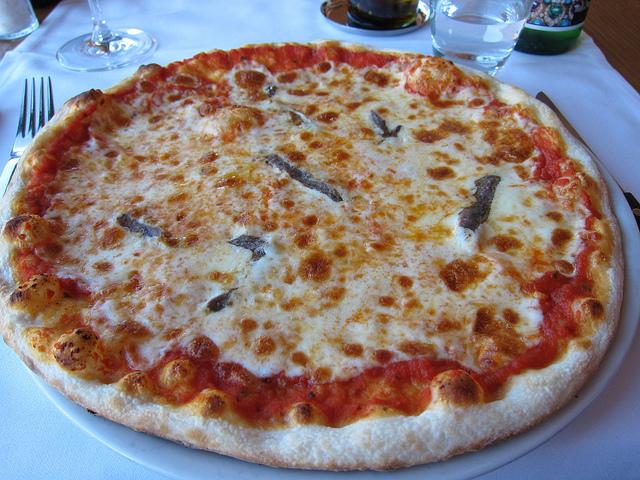Is this edible object high in carbohydrates?
Keep it brief. Yes. Is there any pieces missing?
Keep it brief. No. What toppings are on the pizza?
Answer briefly. Cheese and anchovies. 